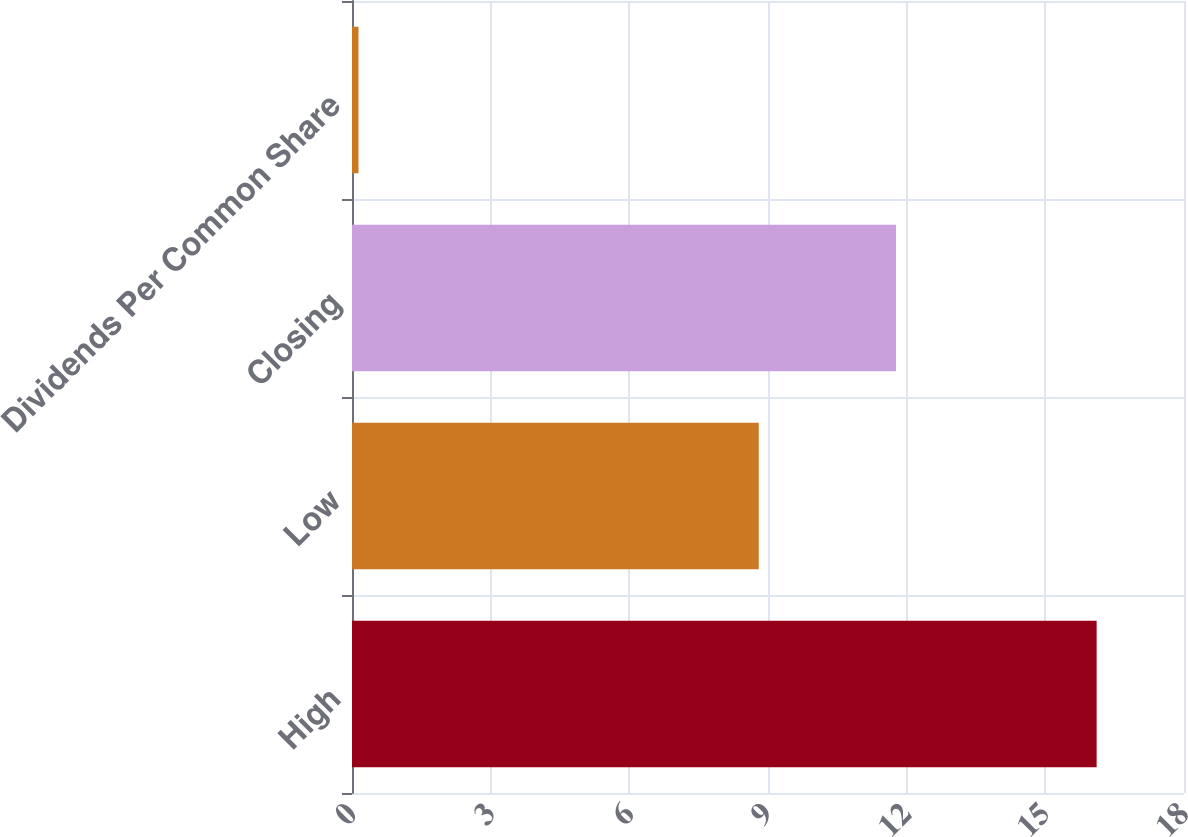Convert chart to OTSL. <chart><loc_0><loc_0><loc_500><loc_500><bar_chart><fcel>High<fcel>Low<fcel>Closing<fcel>Dividends Per Common Share<nl><fcel>16.11<fcel>8.8<fcel>11.77<fcel>0.14<nl></chart> 